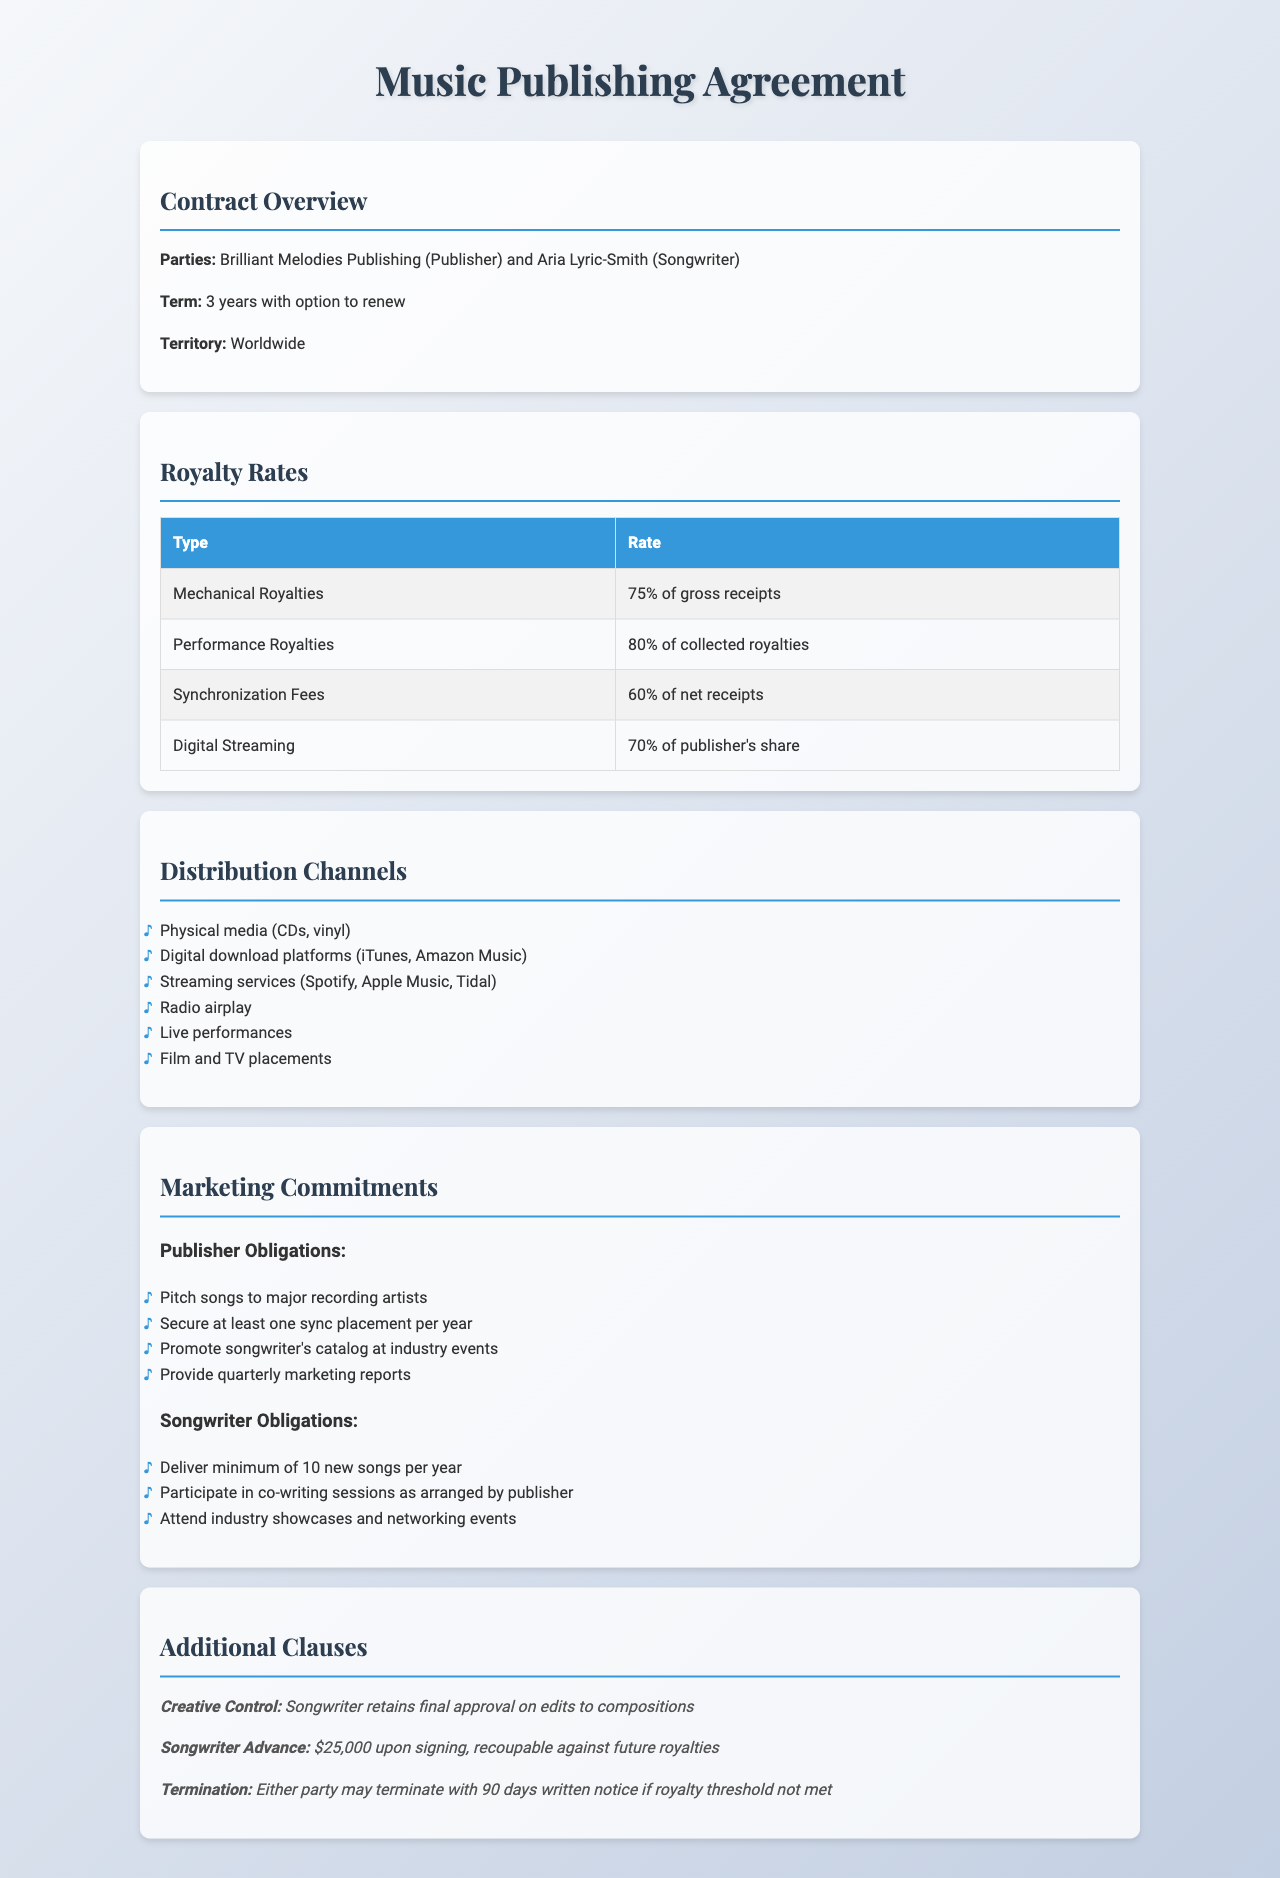what is the publisher's name? The publisher mentioned in the document is Brilliant Melodies Publishing.
Answer: Brilliant Melodies Publishing what is the term of the contract? The term of the contract is specified as 3 years with an option to renew.
Answer: 3 years what percentage of gross receipts are Mechanical Royalties? The document states that Mechanical Royalties amount to 75% of gross receipts.
Answer: 75% of gross receipts how many new songs must the songwriter deliver per year? The requirement in the document is for the songwriter to deliver a minimum of 10 new songs per year.
Answer: 10 what is the songwriter advance amount? The document specifies the songwriter advance as $25,000 upon signing.
Answer: $25,000 which digital platforms are included in the distribution channels? The document lists digital download platforms such as iTunes and Amazon Music in the distribution channels.
Answer: iTunes, Amazon Music what is the performance royalty rate? According to the document, the performance royalty rate is 80% of collected royalties.
Answer: 80% of collected royalties what is one obligation of the publisher regarding marketing? The document mentions that one obligation is to pitch songs to major recording artists.
Answer: Pitch songs to major recording artists what must the songwriter do in co-writing sessions? The document requires the songwriter to participate in co-writing sessions as arranged by the publisher.
Answer: Participate in co-writing sessions 